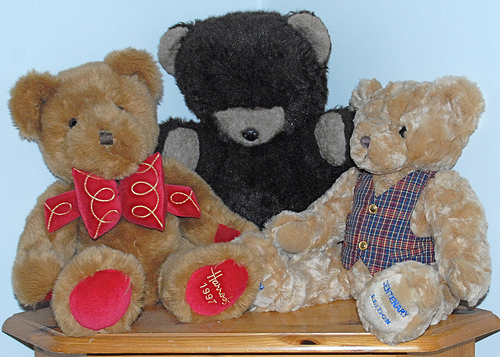<image>
Is there a red bow behind the teddy bear? No. The red bow is not behind the teddy bear. From this viewpoint, the red bow appears to be positioned elsewhere in the scene. Is the paw on the bear? No. The paw is not positioned on the bear. They may be near each other, but the paw is not supported by or resting on top of the bear. Where is the bear in relation to the bear? Is it in front of the bear? No. The bear is not in front of the bear. The spatial positioning shows a different relationship between these objects. Is there a red teddy to the right of the blue teddy? Yes. From this viewpoint, the red teddy is positioned to the right side relative to the blue teddy. 